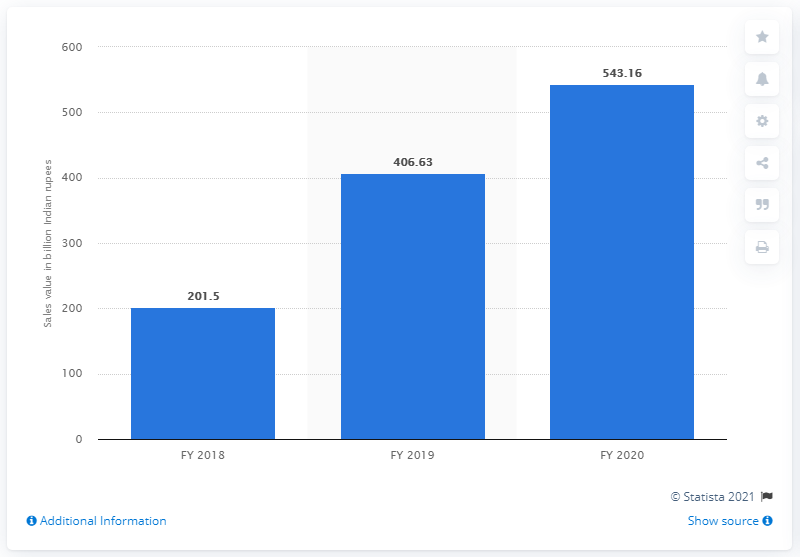Outline some significant characteristics in this image. Reliance Jio Infocomm Limited's net sales in the fiscal year 2020 were 543.16 rupees. 